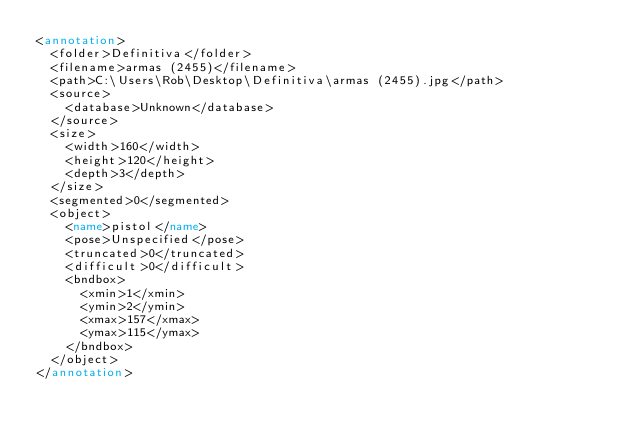Convert code to text. <code><loc_0><loc_0><loc_500><loc_500><_XML_><annotation>
  <folder>Definitiva</folder>
  <filename>armas (2455)</filename>
  <path>C:\Users\Rob\Desktop\Definitiva\armas (2455).jpg</path>
  <source>
    <database>Unknown</database>
  </source>
  <size>
    <width>160</width>
    <height>120</height>
    <depth>3</depth>
  </size>
  <segmented>0</segmented>
  <object>
    <name>pistol</name>
    <pose>Unspecified</pose>
    <truncated>0</truncated>
    <difficult>0</difficult>
    <bndbox>
      <xmin>1</xmin>
      <ymin>2</ymin>
      <xmax>157</xmax>
      <ymax>115</ymax>
    </bndbox>
  </object>
</annotation>
</code> 